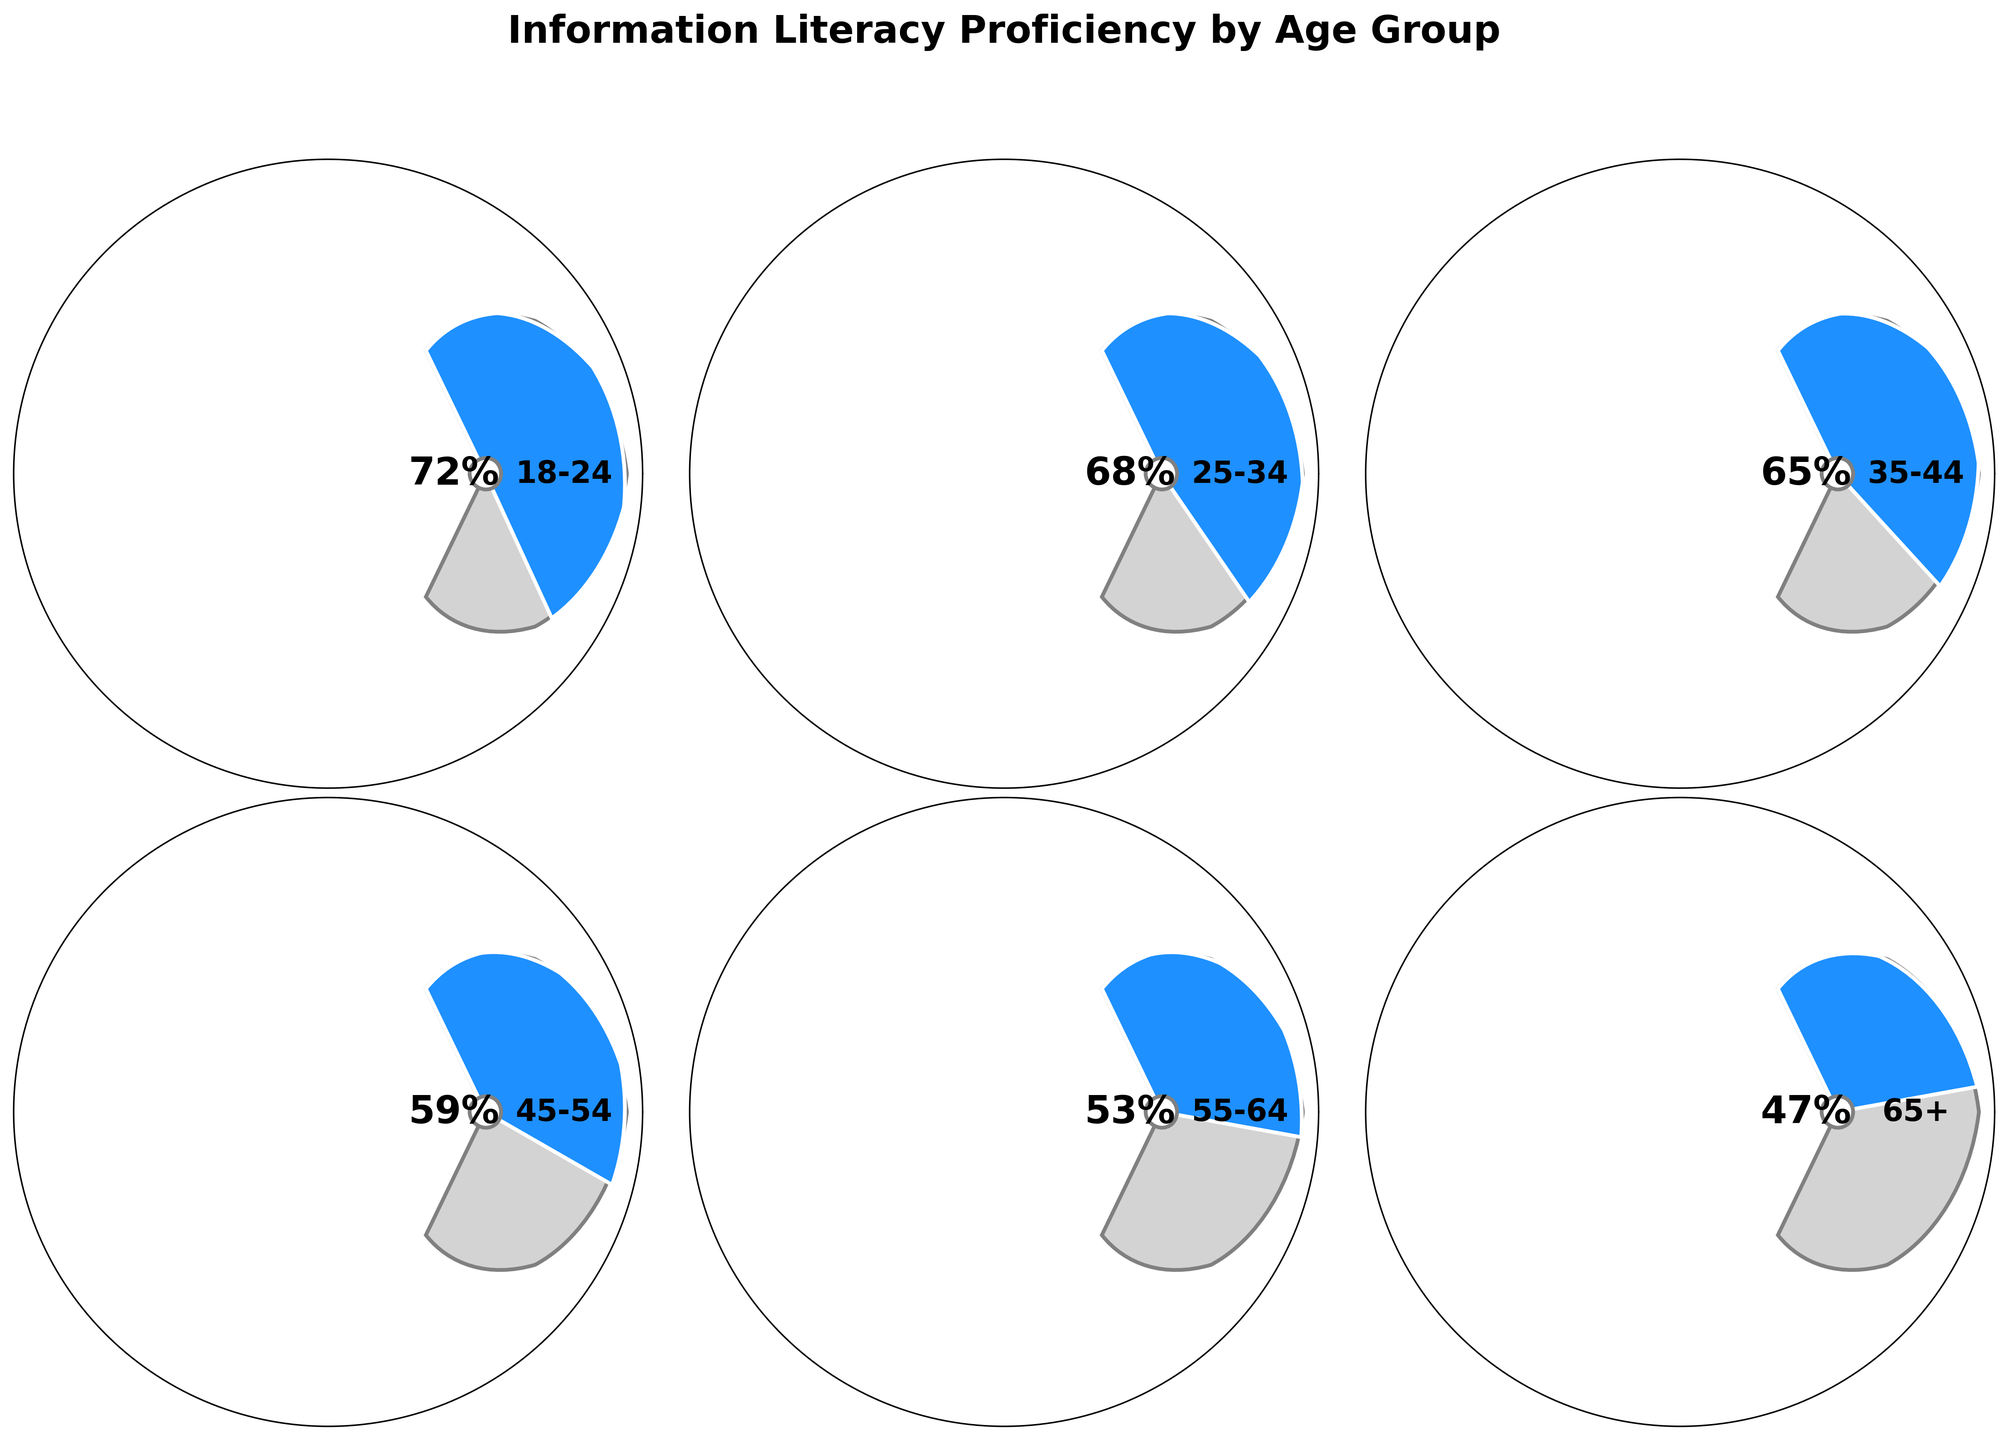What's the title of the figure? The title is displayed at the top of the figure, bolded and larger in font size. It reads "Information Literacy Proficiency by Age Group".
Answer: Information Literacy Proficiency by Age Group Which age group has the highest proficiency? By looking at the values displayed in the gauge charts, the age group 18-24 has the highest proficiency at 72%.
Answer: 18-24 What's the average proficiency level across all age groups? The proficiency levels are 72, 68, 65, 59, 53, and 47. Sum these up to get 72 + 68 + 65 + 59 + 53 + 47 = 364. There are 6 age groups, so the average proficiency is 364/6 = 60.67.
Answer: 60.67 How many age groups have a proficiency level above 60%? The chart shows proficiency levels for 6 age groups. Among them, 18-24, 25-34, and 35-44 have proficiency levels above 60%. That's 3 age groups.
Answer: 3 Which age group has the lowest proficiency? The gauge chart for the age group 65+ shows a proficiency level of 47%, which is the lowest among all age groups.
Answer: 65+ What's the range of proficiency levels displayed? The highest proficiency is 72% (age group 18-24) and the lowest is 47% (age group 65+). The range is 72 - 47 = 25.
Answer: 25 What is the median proficiency level across the age groups? Arrange the proficiency levels in ascending order: 47, 53, 59, 65, 68, 72. There are 6 data points, so the median is the average of the 3rd and 4th values. (59 + 65)/2 = 62.
Answer: 62 Is there a noticeable trend in proficiency levels as age increases? The proficiency levels decrease as the age groups get older, going from 72% in the youngest group (18-24) to 47% in the oldest group (65+). This indicates a downward trend in proficiency with increasing age.
Answer: Yes, a downward trend By how much does the proficiency level of the age group 18-24 exceed that of the 55-64 group? The proficiency level for 18-24 is 72%, and for 55-64 it is 53%. The difference is 72 - 53 = 19.
Answer: 19 Which age group has a proficiency level closest to 60%? Looking at the gauge charts, the age group 45-54 has a proficiency level of 59%, which is closest to 60%.
Answer: 45-54 